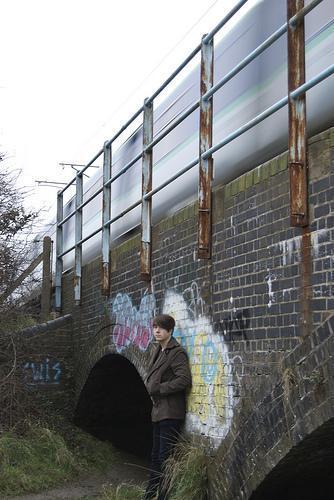How many people are in photo?
Give a very brief answer. 1. 